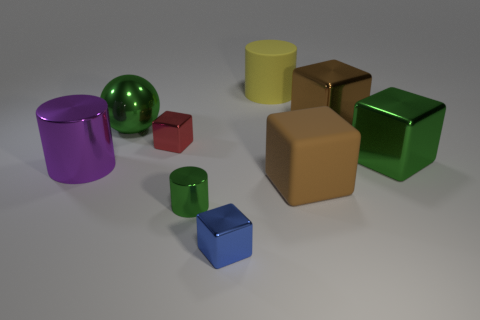There is a tiny thing that is the same color as the sphere; what is it made of?
Your answer should be very brief. Metal. How many big objects are purple shiny things or brown matte objects?
Provide a succinct answer. 2. The rubber cylinder has what color?
Your answer should be compact. Yellow. There is a big brown block that is behind the purple metal cylinder; is there a large rubber cylinder that is right of it?
Keep it short and to the point. No. Is the number of small metal cubes behind the matte block less than the number of blue things?
Give a very brief answer. No. Do the big green object right of the blue metallic cube and the yellow thing have the same material?
Your answer should be compact. No. What is the color of the big cylinder that is the same material as the blue cube?
Give a very brief answer. Purple. Are there fewer cylinders that are to the left of the sphere than objects that are on the left side of the red thing?
Offer a terse response. Yes. There is a big block behind the tiny red metallic thing; does it have the same color as the big rubber thing that is on the right side of the yellow object?
Offer a terse response. Yes. Are there any spheres that have the same material as the purple object?
Give a very brief answer. Yes. 